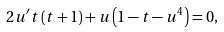<formula> <loc_0><loc_0><loc_500><loc_500>2 u ^ { \prime } t \left ( t + 1 \right ) + u \left ( 1 - t - u ^ { 4 } \right ) = 0 ,</formula> 